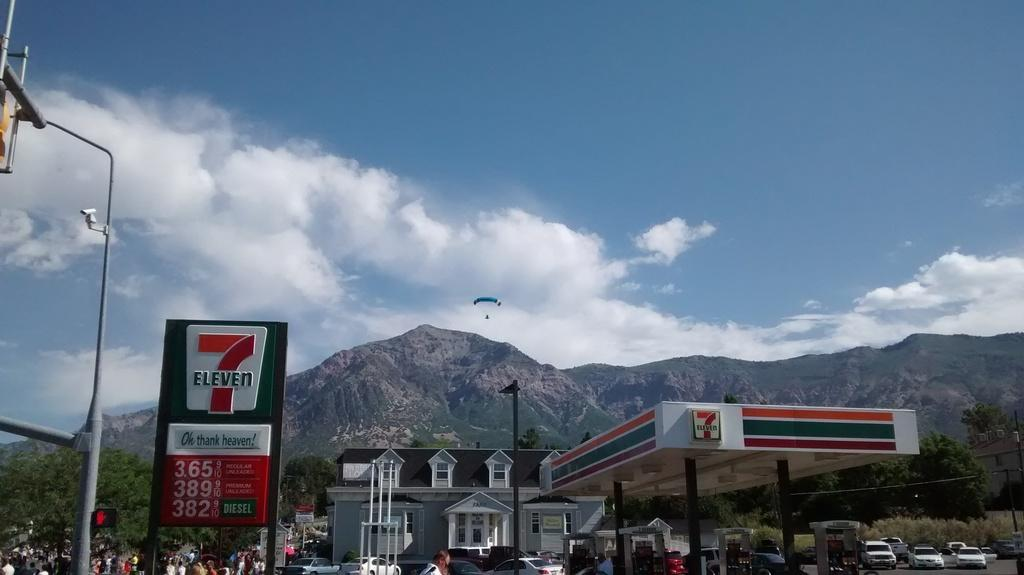What can be seen in the foreground of the image? In the foreground of the image, there are vehicles, people, a house, poles, and a roof. What is the primary focus of the foreground? The primary focus of the foreground is the vehicles, people, and house. What can be seen in the background of the image? In the background of the image, there are mountains, a parachute, and the sky. What is the most prominent feature in the background? The most prominent feature in the background is the mountains. Where is the porter carrying his luggage in the image? There is no porter carrying luggage in the image. What type of pin is attached to the parachute in the image? There is no pin visible on the parachute in the image. 